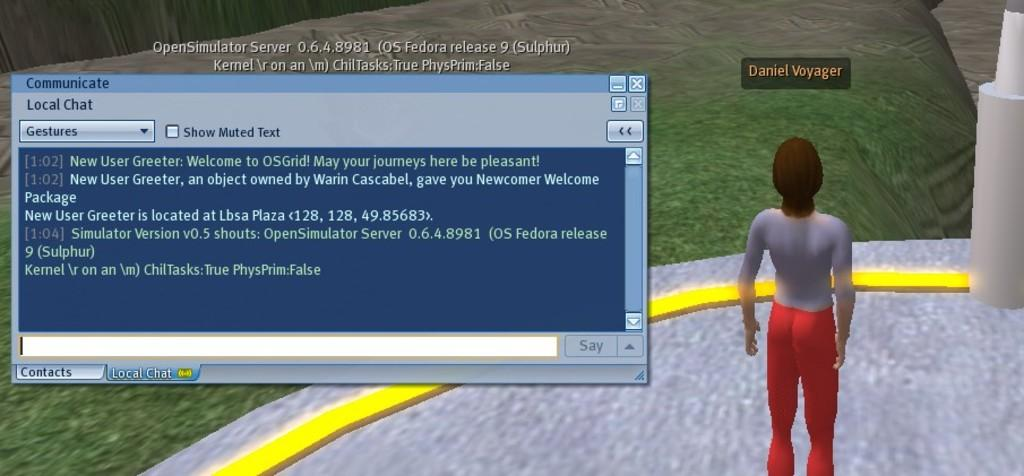What type of image is being described? The image is an animation. Can you describe the person in the image? There is a person on the right side of the image. What else can be seen in the image besides the person? There is some text on the left side of the image. What type of flowers are growing in the box on the left side of the image? There is no box or flowers present in the image; it is an animation with a person and text. 